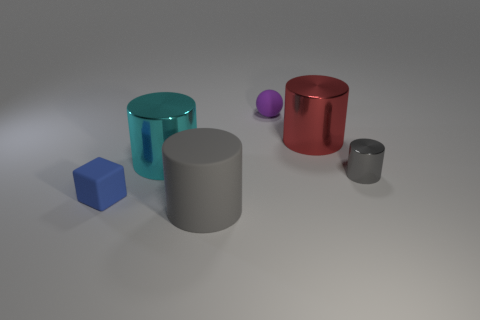There is a rubber thing on the left side of the large cylinder on the left side of the large object that is in front of the cyan shiny cylinder; what size is it? The rubber item to the left of the large cylinder, which appears to be a small purple sphere, is relatively small compared to the surrounding objects. It is noticeably smaller than any of the other objects in the scene, suggesting it could be a small bouncy ball or a similar object. 